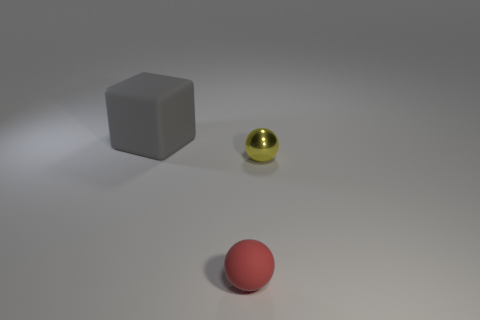There is a object that is behind the red sphere and left of the yellow thing; what size is it? The object behind the red sphere and to the left of the yellow sphere is a medium-sized grey cube. 